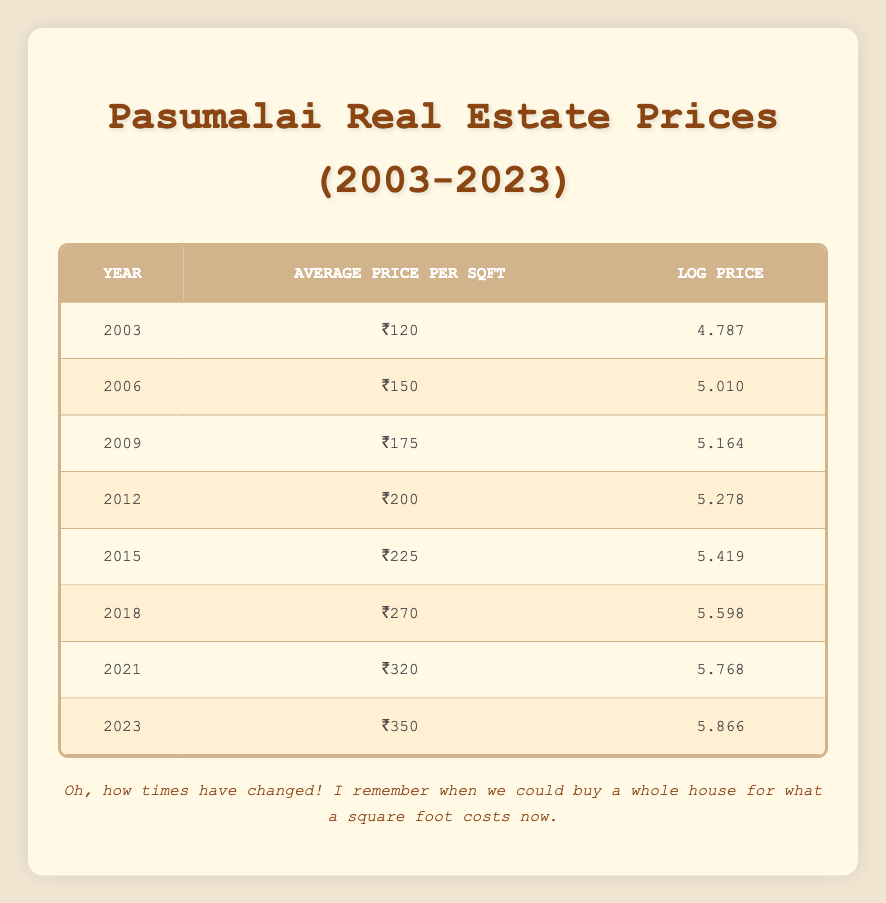What was the average price per square foot in 2006? Referring to the table, the average price per square foot in 2006 is listed directly.
Answer: ₹150 What is the log price for the year 2021? The log price for the year 2021 is clearly shown in the corresponding row of the table.
Answer: 5.768 Which year saw the highest average price per square foot? The table shows average prices from each year. By inspecting the values, 2023 has the highest average price of ₹350.
Answer: 2023 What is the difference in average price per square foot between 2009 and 2015? The average price in 2009 is ₹175 and in 2015 is ₹225. The difference is calculated as ₹225 - ₹175 = ₹50.
Answer: ₹50 Is the average price per square foot in 2018 greater than that in 2012? In the table, the average price in 2018 is ₹270, and in 2012, it is ₹200. Since 270 > 200, the statement is true.
Answer: Yes What was the percentage increase in average price per square foot from 2003 to 2023? The starting price in 2003 is ₹120 and the ending price in 2023 is ₹350. The increase is ₹350 - ₹120 = ₹230. The percentage increase is (230/120) * 100 = 191.67%.
Answer: 191.67% What is the average of the log prices from 2003 to 2023? The log prices provided are 4.787, 5.010, 5.164, 5.278, 5.419, 5.598, 5.768, and 5.866. The average is calculated as (4.787 + 5.010 + 5.164 + 5.278 + 5.419 + 5.598 + 5.768 + 5.866) / 8 = 5.419.
Answer: 5.419 Was the average price per square foot in any year below ₹150? Looking at the table, the years 2003 (₹120) and 2006 (₹150) both indicate that there was a year with an average below ₹150.
Answer: Yes In which year was the log price closest to 5.5? Reviewing the log prices, 5.598 in 2018 is closest to 5.5 when compared to other values, making it the year where the log price is nearest to that figure.
Answer: 2018 